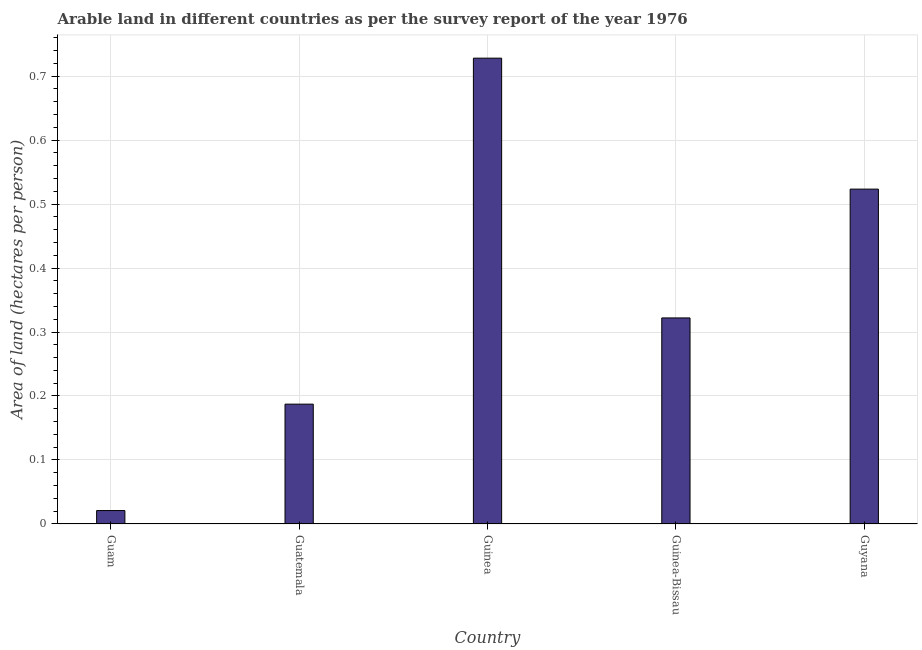Does the graph contain grids?
Your answer should be very brief. Yes. What is the title of the graph?
Keep it short and to the point. Arable land in different countries as per the survey report of the year 1976. What is the label or title of the Y-axis?
Make the answer very short. Area of land (hectares per person). What is the area of arable land in Guyana?
Your response must be concise. 0.52. Across all countries, what is the maximum area of arable land?
Your answer should be very brief. 0.73. Across all countries, what is the minimum area of arable land?
Offer a terse response. 0.02. In which country was the area of arable land maximum?
Provide a succinct answer. Guinea. In which country was the area of arable land minimum?
Offer a terse response. Guam. What is the sum of the area of arable land?
Provide a succinct answer. 1.78. What is the difference between the area of arable land in Guatemala and Guinea?
Your answer should be compact. -0.54. What is the average area of arable land per country?
Make the answer very short. 0.36. What is the median area of arable land?
Offer a very short reply. 0.32. In how many countries, is the area of arable land greater than 0.5 hectares per person?
Your response must be concise. 2. What is the ratio of the area of arable land in Guatemala to that in Guinea-Bissau?
Your response must be concise. 0.58. What is the difference between the highest and the second highest area of arable land?
Make the answer very short. 0.2. What is the difference between the highest and the lowest area of arable land?
Your answer should be compact. 0.71. Are all the bars in the graph horizontal?
Your answer should be compact. No. What is the difference between two consecutive major ticks on the Y-axis?
Keep it short and to the point. 0.1. Are the values on the major ticks of Y-axis written in scientific E-notation?
Provide a succinct answer. No. What is the Area of land (hectares per person) of Guam?
Give a very brief answer. 0.02. What is the Area of land (hectares per person) in Guatemala?
Offer a terse response. 0.19. What is the Area of land (hectares per person) of Guinea?
Ensure brevity in your answer.  0.73. What is the Area of land (hectares per person) of Guinea-Bissau?
Provide a short and direct response. 0.32. What is the Area of land (hectares per person) of Guyana?
Offer a very short reply. 0.52. What is the difference between the Area of land (hectares per person) in Guam and Guatemala?
Make the answer very short. -0.17. What is the difference between the Area of land (hectares per person) in Guam and Guinea?
Provide a short and direct response. -0.71. What is the difference between the Area of land (hectares per person) in Guam and Guinea-Bissau?
Your answer should be very brief. -0.3. What is the difference between the Area of land (hectares per person) in Guam and Guyana?
Ensure brevity in your answer.  -0.5. What is the difference between the Area of land (hectares per person) in Guatemala and Guinea?
Give a very brief answer. -0.54. What is the difference between the Area of land (hectares per person) in Guatemala and Guinea-Bissau?
Give a very brief answer. -0.13. What is the difference between the Area of land (hectares per person) in Guatemala and Guyana?
Provide a short and direct response. -0.34. What is the difference between the Area of land (hectares per person) in Guinea and Guinea-Bissau?
Ensure brevity in your answer.  0.41. What is the difference between the Area of land (hectares per person) in Guinea and Guyana?
Offer a terse response. 0.2. What is the difference between the Area of land (hectares per person) in Guinea-Bissau and Guyana?
Your answer should be very brief. -0.2. What is the ratio of the Area of land (hectares per person) in Guam to that in Guatemala?
Your response must be concise. 0.11. What is the ratio of the Area of land (hectares per person) in Guam to that in Guinea?
Offer a terse response. 0.03. What is the ratio of the Area of land (hectares per person) in Guam to that in Guinea-Bissau?
Your response must be concise. 0.07. What is the ratio of the Area of land (hectares per person) in Guam to that in Guyana?
Give a very brief answer. 0.04. What is the ratio of the Area of land (hectares per person) in Guatemala to that in Guinea?
Offer a very short reply. 0.26. What is the ratio of the Area of land (hectares per person) in Guatemala to that in Guinea-Bissau?
Ensure brevity in your answer.  0.58. What is the ratio of the Area of land (hectares per person) in Guatemala to that in Guyana?
Provide a succinct answer. 0.36. What is the ratio of the Area of land (hectares per person) in Guinea to that in Guinea-Bissau?
Make the answer very short. 2.26. What is the ratio of the Area of land (hectares per person) in Guinea to that in Guyana?
Your answer should be very brief. 1.39. What is the ratio of the Area of land (hectares per person) in Guinea-Bissau to that in Guyana?
Offer a very short reply. 0.61. 